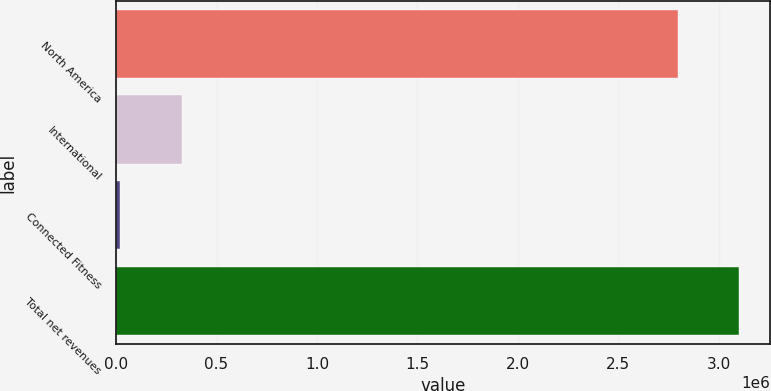Convert chart. <chart><loc_0><loc_0><loc_500><loc_500><bar_chart><fcel>North America<fcel>International<fcel>Connected Fitness<fcel>Total net revenues<nl><fcel>2.79637e+06<fcel>325740<fcel>19225<fcel>3.10289e+06<nl></chart> 